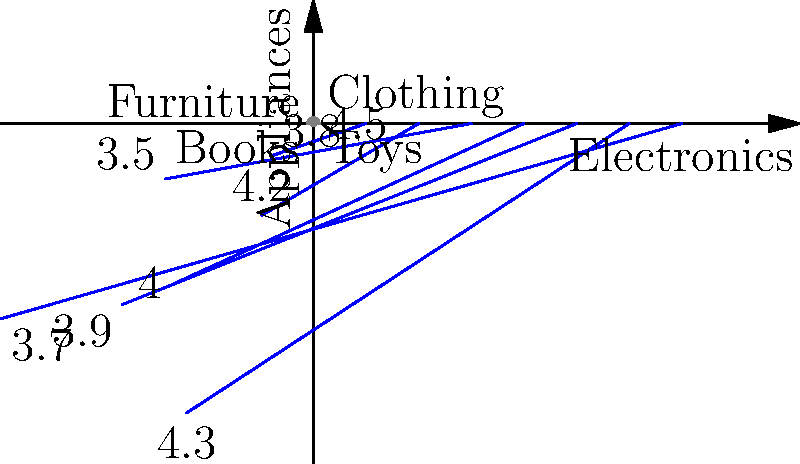As a business school student from the Brown family, you're analyzing customer satisfaction data for Brown's Department Store. The polar rose diagram shows ratings across 8 product categories. What is the average customer satisfaction rating, and which category has the highest rating? To solve this problem, we'll follow these steps:

1. Identify all ratings from the polar rose diagram:
   Electronics: 4.5
   Appliances: 3.8
   Clothing: 4.2
   Furniture: 3.5
   Books: 4.0
   Toys: 4.3
   Home Decor: 3.9
   Kitchenware: 3.7

2. Calculate the average rating:
   $\text{Average} = \frac{\sum \text{ratings}}{\text{number of categories}}$
   $= \frac{4.5 + 3.8 + 4.2 + 3.5 + 4.0 + 4.3 + 3.9 + 3.7}{8}$
   $= \frac{31.9}{8} = 3.9875$

3. Identify the highest rating:
   The highest rating is 4.5, which corresponds to the Electronics category.

Therefore, the average customer satisfaction rating is 3.99 (rounded to two decimal places), and the category with the highest rating is Electronics at 4.5.
Answer: Average: 3.99; Highest: Electronics (4.5) 